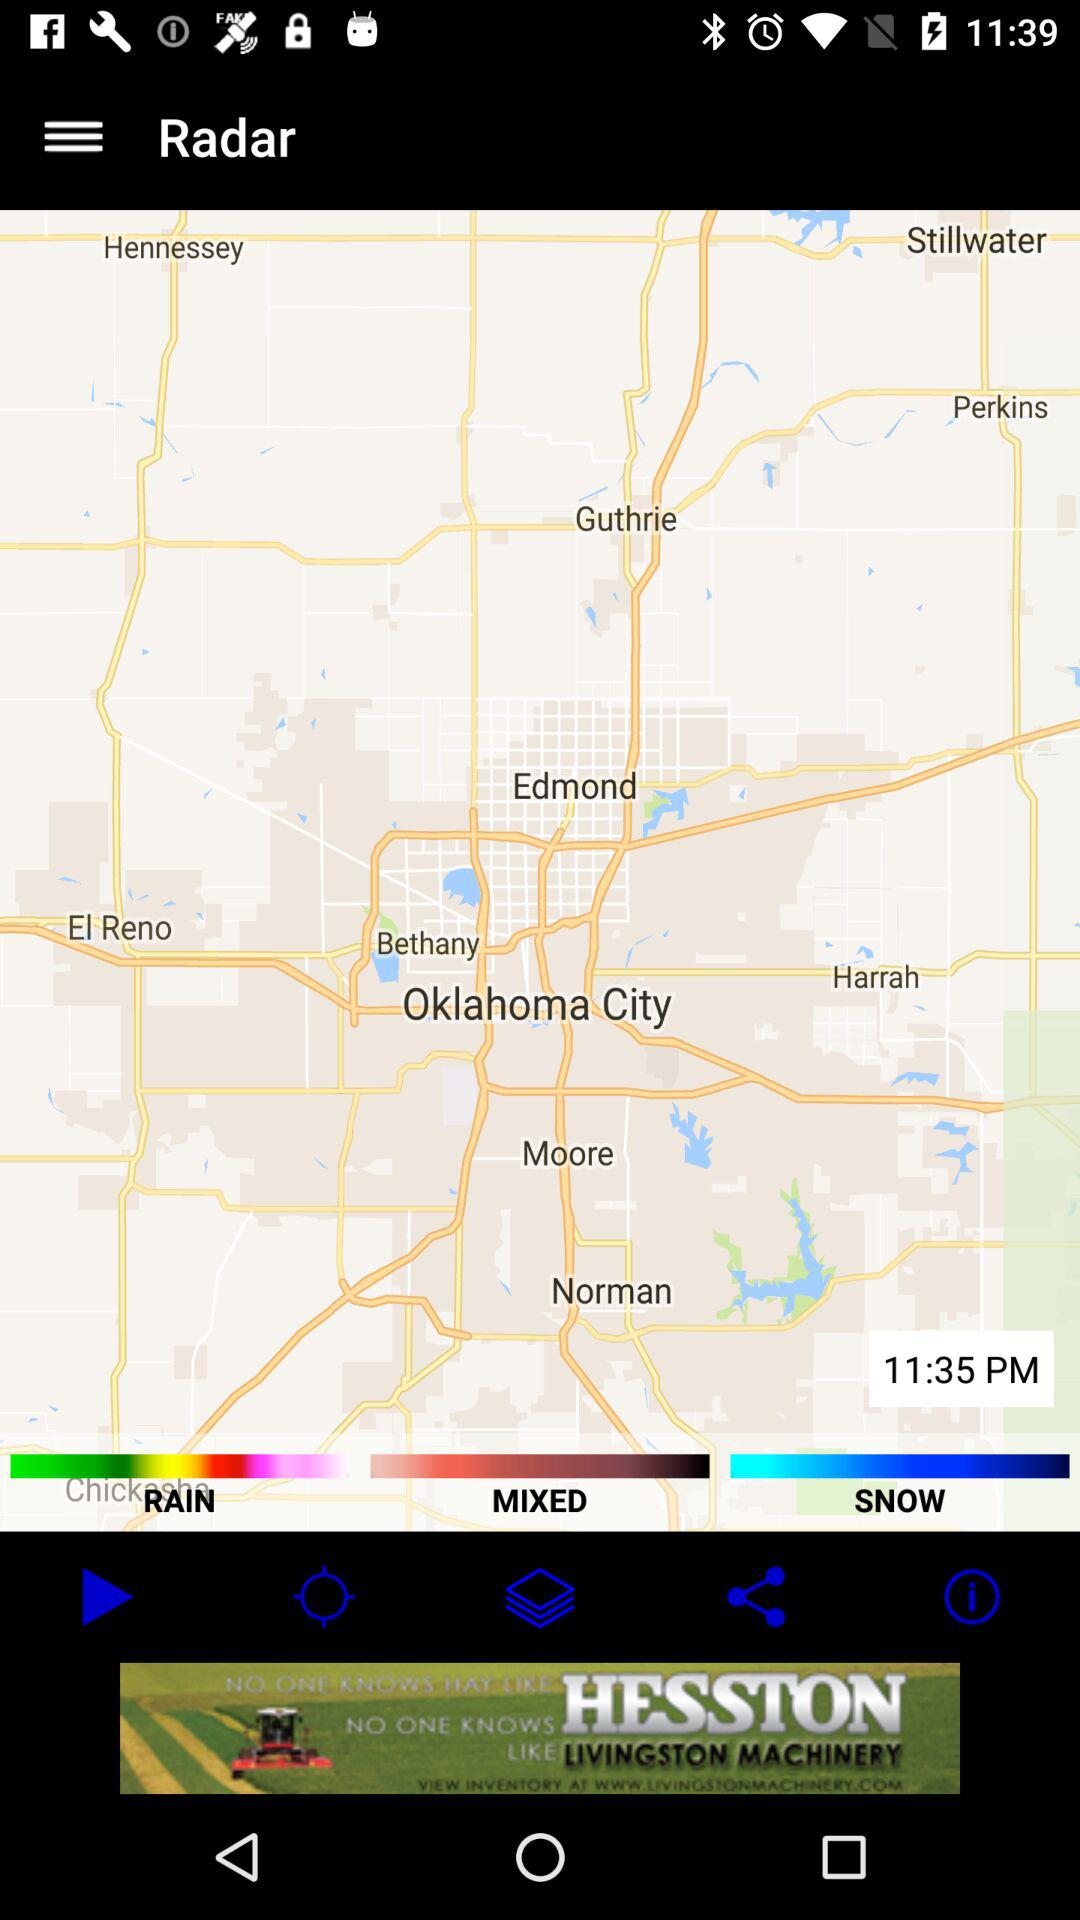What is the selected time? The selected time is 11:35 PM. 